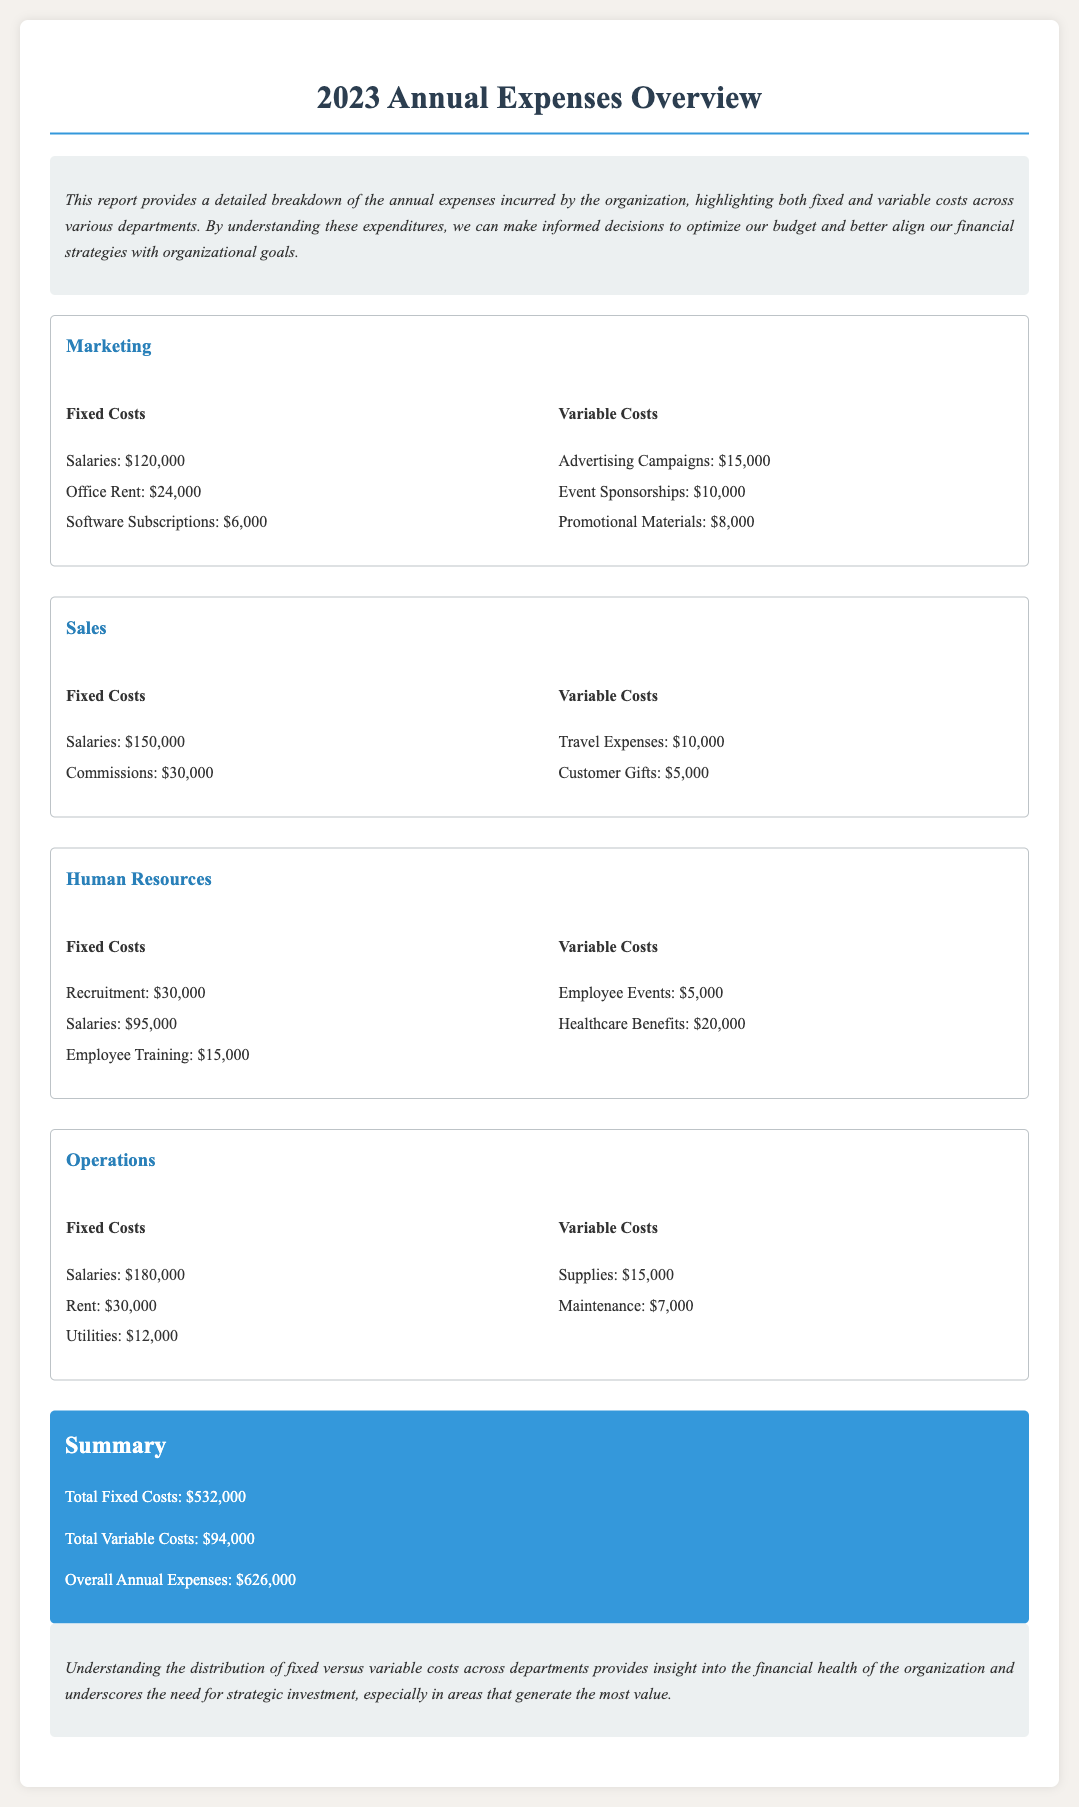What are the total fixed costs? The total fixed costs are provided in the summary section of the document.
Answer: $532,000 What is the variable cost for Employee Events? The variable cost for Employee Events is listed in the Human Resources department section.
Answer: $5,000 Which department has the highest fixed costs? To determine this, we analyze the fixed costs listed for each department; Operations has the highest total fixed costs.
Answer: Operations What is the total for Advertising Campaigns? The cost for Advertising Campaigns can be found in the Marketing department's variable costs.
Answer: $15,000 How much is spent on Salaries in the Sales department? The salaries in the Sales department are clearly stated under fixed costs.
Answer: $150,000 What is the overall annual expense amount? The overall annual expenses are summarized at the end of the document.
Answer: $626,000 What are the total variable costs? The total variable costs are provided in the summary section of the document.
Answer: $94,000 How much is allocated for Utilities in Operations? The amount for Utilities is specified in Operations' fixed costs section.
Answer: $12,000 What is the total for Healthcare Benefits? The cost for Healthcare Benefits can be found in the variable costs listed under Human Resources.
Answer: $20,000 